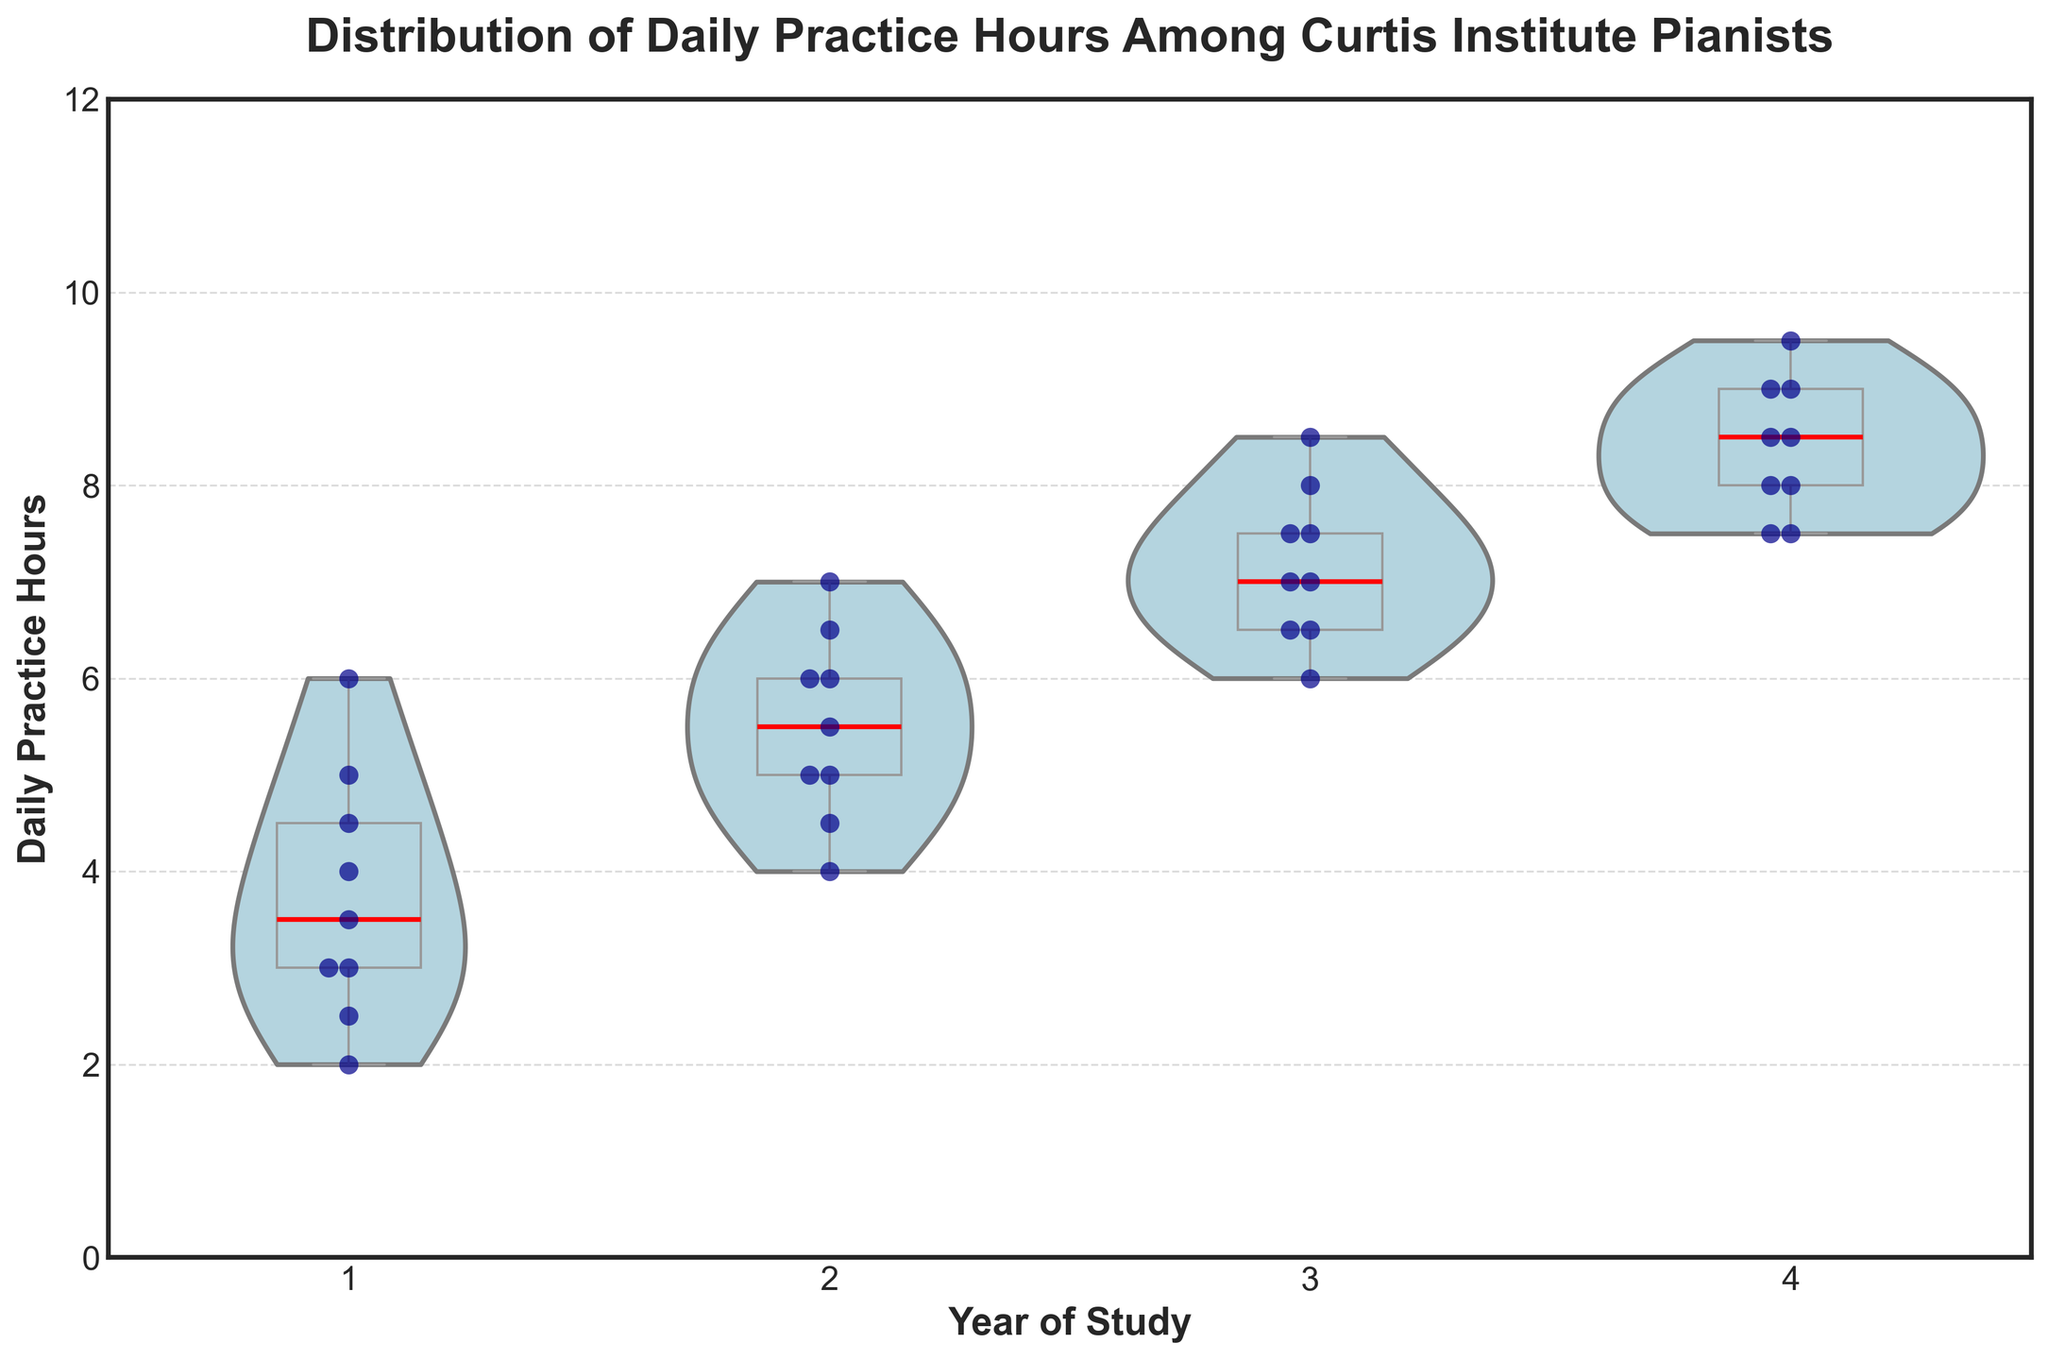What is the title of the figure? The title is displayed at the top of the figure in bold text. It states "Distribution of Daily Practice Hours Among Curtis Institute Pianists."
Answer: Distribution of Daily Practice Hours Among Curtis Institute Pianists What is the range of the y-axis? The y-axis range can be determined by looking at its minimum and maximum values, labeled on the axis. The minimum value is 0 and the maximum value is 12.
Answer: 0 to 12 Which year has the highest median daily practice hours? The median daily practice hours for each year can be identified by the red line in the box plot overlay. The year with the highest positioned red line will have the highest median.
Answer: Year 4 How many different years of study are represented in the data? By looking at the x-axis categories, we see the figure breaks down the practice hours by Year of Study, which includes 1, 2, 3, and 4, representing four different years.
Answer: 4 Describe how the daily practice hours trend as the year of study increases. Observing the position and spread of the violins and the box plots, practice hours generally increase with each year. Year 1 has the lowest values, while Year 4 has the highest values.
Answer: Practice hours increase How many data points are there for Year 4? By counting the individual points displayed within the swarm plot for Year 4, the figure shows how many data points there are.
Answer: 9 Which year of study has the widest range of daily practice hours? The range can be determined by the length of the violins and box plots. The wider the violin and longer the box, the wider the range of practice hours.
Answer: Year 1 What are the lower and upper quartiles for Year 2? The lower and upper quartiles for Year 2 can be seen as the bottom and top edges of the box in the box plot. The lower quartile looks to be around 4.5 hours, and the upper quartile looks to be around 6.0 hours.
Answer: 4.5 to 6.0 hours Compare the median practice hours between Year 1 and Year 3. Which is higher and by how much? The median practice hours are represented by the red lines in each box plot. Year 1's median is around 3.0 hours, while Year 3's median is around 7.0 hours. The difference is 7.0 - 3.0 = 4.0 hours.
Answer: Year 3 by 4 hours Which year shows the least variability in daily practice hours? Variability can be assessed by the spread of the violins and the height of the box plots. The year with the shortest box plot and narrowest violin indicates the least variability.
Answer: Year 4 